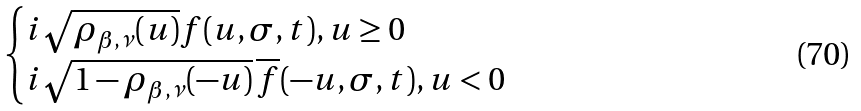Convert formula to latex. <formula><loc_0><loc_0><loc_500><loc_500>\begin{cases} i \sqrt { \rho _ { \beta , \nu } ( u ) } f ( u , \sigma , t ) , u \geq 0 \\ i \sqrt { 1 - \rho _ { \beta , \nu } ( - u ) } \, \overline { f } ( - u , \sigma , t ) , u < 0 \end{cases}</formula> 